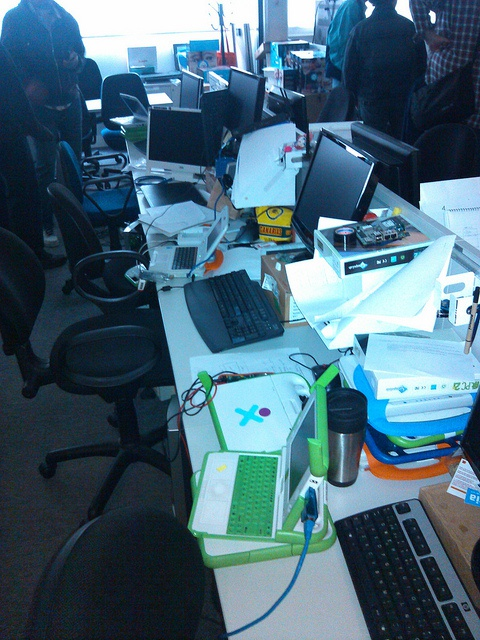Describe the objects in this image and their specific colors. I can see chair in white, black, navy, teal, and green tones, chair in white, black, navy, blue, and teal tones, laptop in white, lightblue, green, and teal tones, keyboard in white, black, gray, and navy tones, and people in white, navy, and blue tones in this image. 